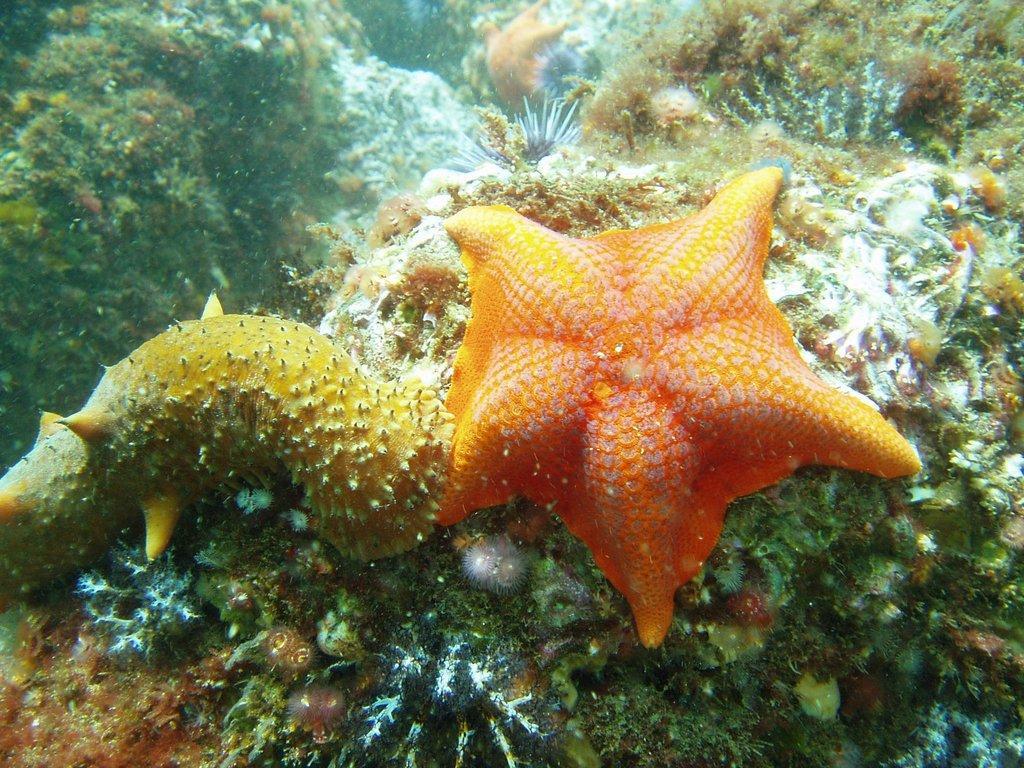Please provide a concise description of this image. In this picture we can see a starfish in the water. 